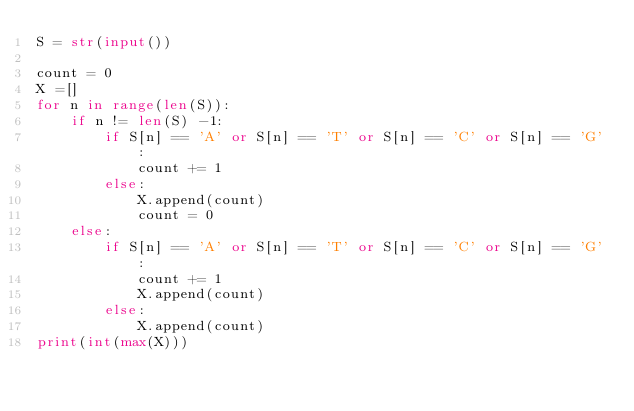Convert code to text. <code><loc_0><loc_0><loc_500><loc_500><_Python_>S = str(input())

count = 0
X =[]
for n in range(len(S)):
    if n != len(S) -1:
        if S[n] == 'A' or S[n] == 'T' or S[n] == 'C' or S[n] == 'G':
            count += 1
        else:
            X.append(count)
            count = 0
    else:
        if S[n] == 'A' or S[n] == 'T' or S[n] == 'C' or S[n] == 'G':
            count += 1
            X.append(count)
        else:
            X.append(count)
print(int(max(X)))</code> 